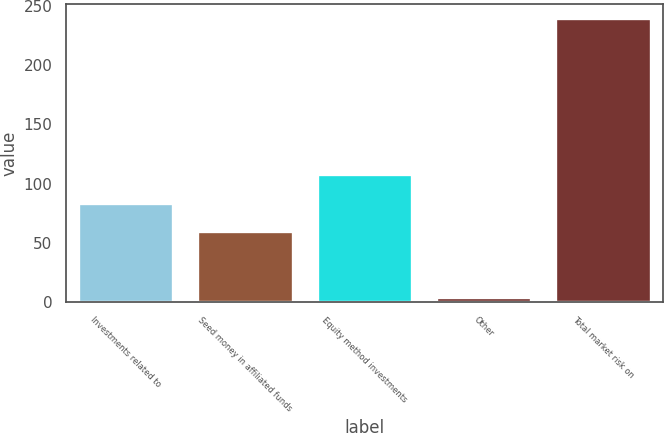Convert chart to OTSL. <chart><loc_0><loc_0><loc_500><loc_500><bar_chart><fcel>Investments related to<fcel>Seed money in affiliated funds<fcel>Equity method investments<fcel>Other<fcel>Total market risk on<nl><fcel>83.33<fcel>59.8<fcel>107.8<fcel>4.2<fcel>239.5<nl></chart> 